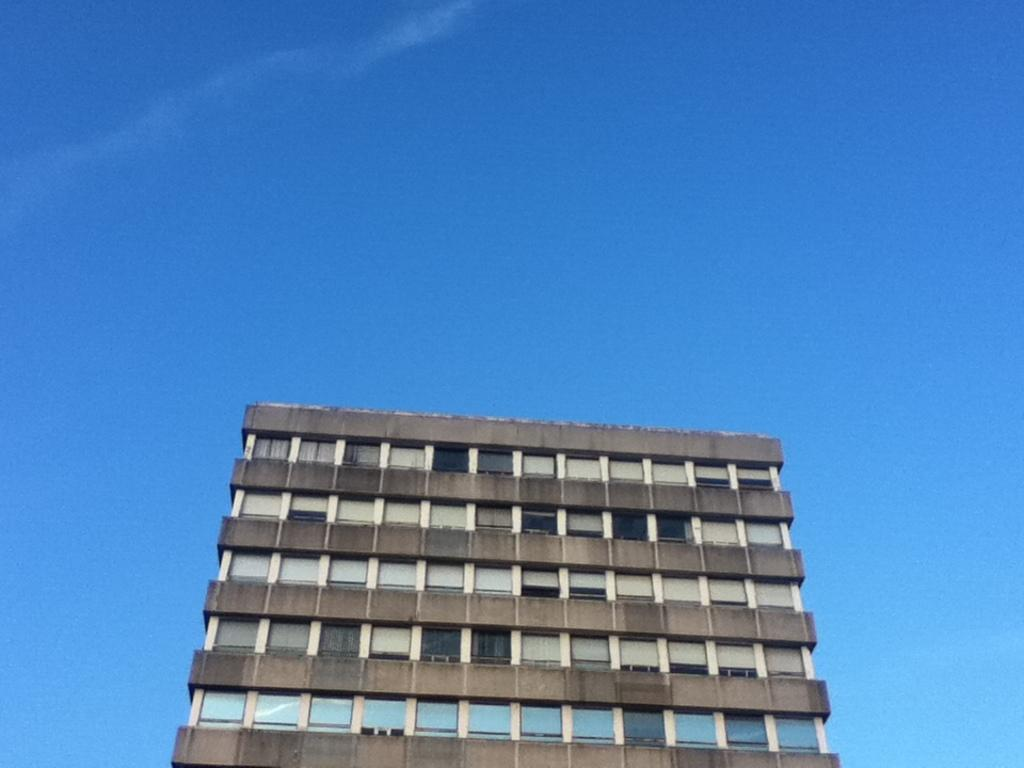What is the main subject in the center of the image? There is a building in the center of the image. What can be seen in the background of the image? The sky is visible in the background of the image. How many cracks can be seen on the bridge in the image? There is no bridge present in the image; it only features a building and the sky. 